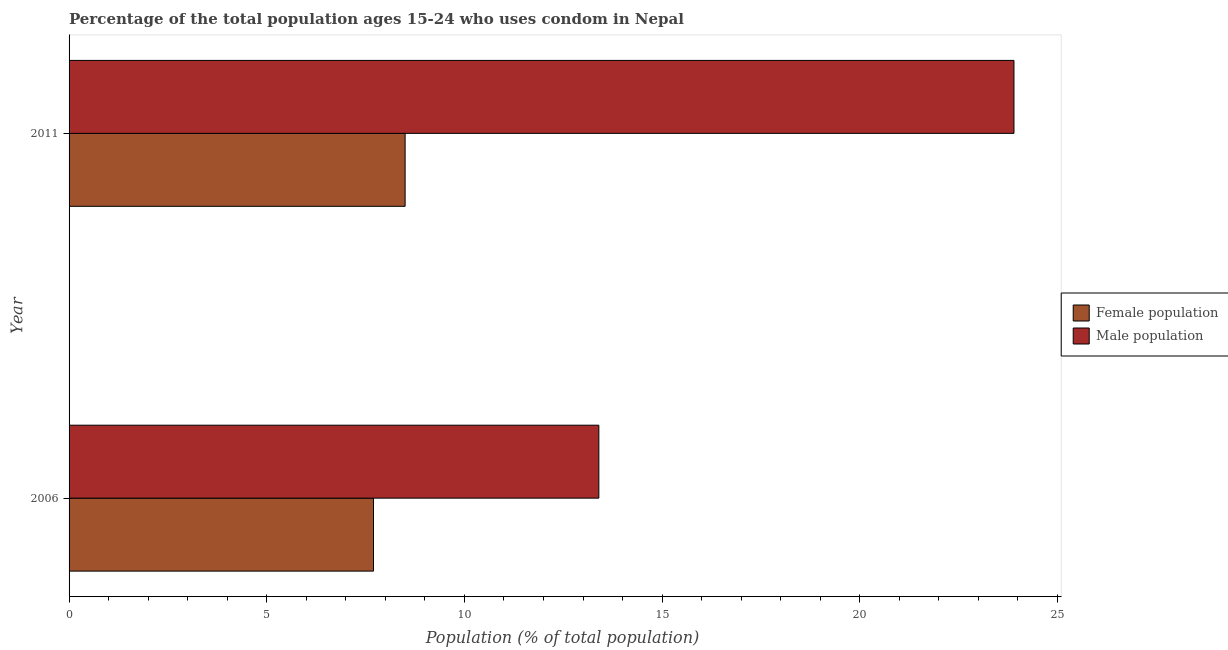How many different coloured bars are there?
Offer a very short reply. 2. Are the number of bars per tick equal to the number of legend labels?
Keep it short and to the point. Yes. Are the number of bars on each tick of the Y-axis equal?
Give a very brief answer. Yes. What is the label of the 1st group of bars from the top?
Make the answer very short. 2011. In how many cases, is the number of bars for a given year not equal to the number of legend labels?
Make the answer very short. 0. What is the total female population in the graph?
Provide a succinct answer. 16.2. What is the difference between the male population in 2006 and that in 2011?
Give a very brief answer. -10.5. What is the difference between the female population in 2006 and the male population in 2011?
Offer a very short reply. -16.2. In the year 2011, what is the difference between the male population and female population?
Ensure brevity in your answer.  15.4. What is the ratio of the male population in 2006 to that in 2011?
Your response must be concise. 0.56. Is the difference between the female population in 2006 and 2011 greater than the difference between the male population in 2006 and 2011?
Your answer should be very brief. Yes. In how many years, is the male population greater than the average male population taken over all years?
Offer a very short reply. 1. What does the 1st bar from the top in 2006 represents?
Keep it short and to the point. Male population. What does the 2nd bar from the bottom in 2011 represents?
Provide a short and direct response. Male population. How many bars are there?
Give a very brief answer. 4. Are all the bars in the graph horizontal?
Your answer should be very brief. Yes. How many years are there in the graph?
Keep it short and to the point. 2. Are the values on the major ticks of X-axis written in scientific E-notation?
Keep it short and to the point. No. How are the legend labels stacked?
Make the answer very short. Vertical. What is the title of the graph?
Your answer should be compact. Percentage of the total population ages 15-24 who uses condom in Nepal. Does "From World Bank" appear as one of the legend labels in the graph?
Your response must be concise. No. What is the label or title of the X-axis?
Your response must be concise. Population (% of total population) . What is the Population (% of total population)  in Male population in 2011?
Provide a short and direct response. 23.9. Across all years, what is the maximum Population (% of total population)  in Female population?
Provide a succinct answer. 8.5. Across all years, what is the maximum Population (% of total population)  of Male population?
Your answer should be very brief. 23.9. Across all years, what is the minimum Population (% of total population)  in Female population?
Keep it short and to the point. 7.7. Across all years, what is the minimum Population (% of total population)  in Male population?
Offer a terse response. 13.4. What is the total Population (% of total population)  of Male population in the graph?
Ensure brevity in your answer.  37.3. What is the difference between the Population (% of total population)  of Male population in 2006 and that in 2011?
Give a very brief answer. -10.5. What is the difference between the Population (% of total population)  in Female population in 2006 and the Population (% of total population)  in Male population in 2011?
Make the answer very short. -16.2. What is the average Population (% of total population)  in Male population per year?
Offer a very short reply. 18.65. In the year 2011, what is the difference between the Population (% of total population)  in Female population and Population (% of total population)  in Male population?
Your answer should be very brief. -15.4. What is the ratio of the Population (% of total population)  of Female population in 2006 to that in 2011?
Make the answer very short. 0.91. What is the ratio of the Population (% of total population)  of Male population in 2006 to that in 2011?
Offer a very short reply. 0.56. What is the difference between the highest and the second highest Population (% of total population)  in Female population?
Offer a terse response. 0.8. What is the difference between the highest and the lowest Population (% of total population)  in Male population?
Keep it short and to the point. 10.5. 